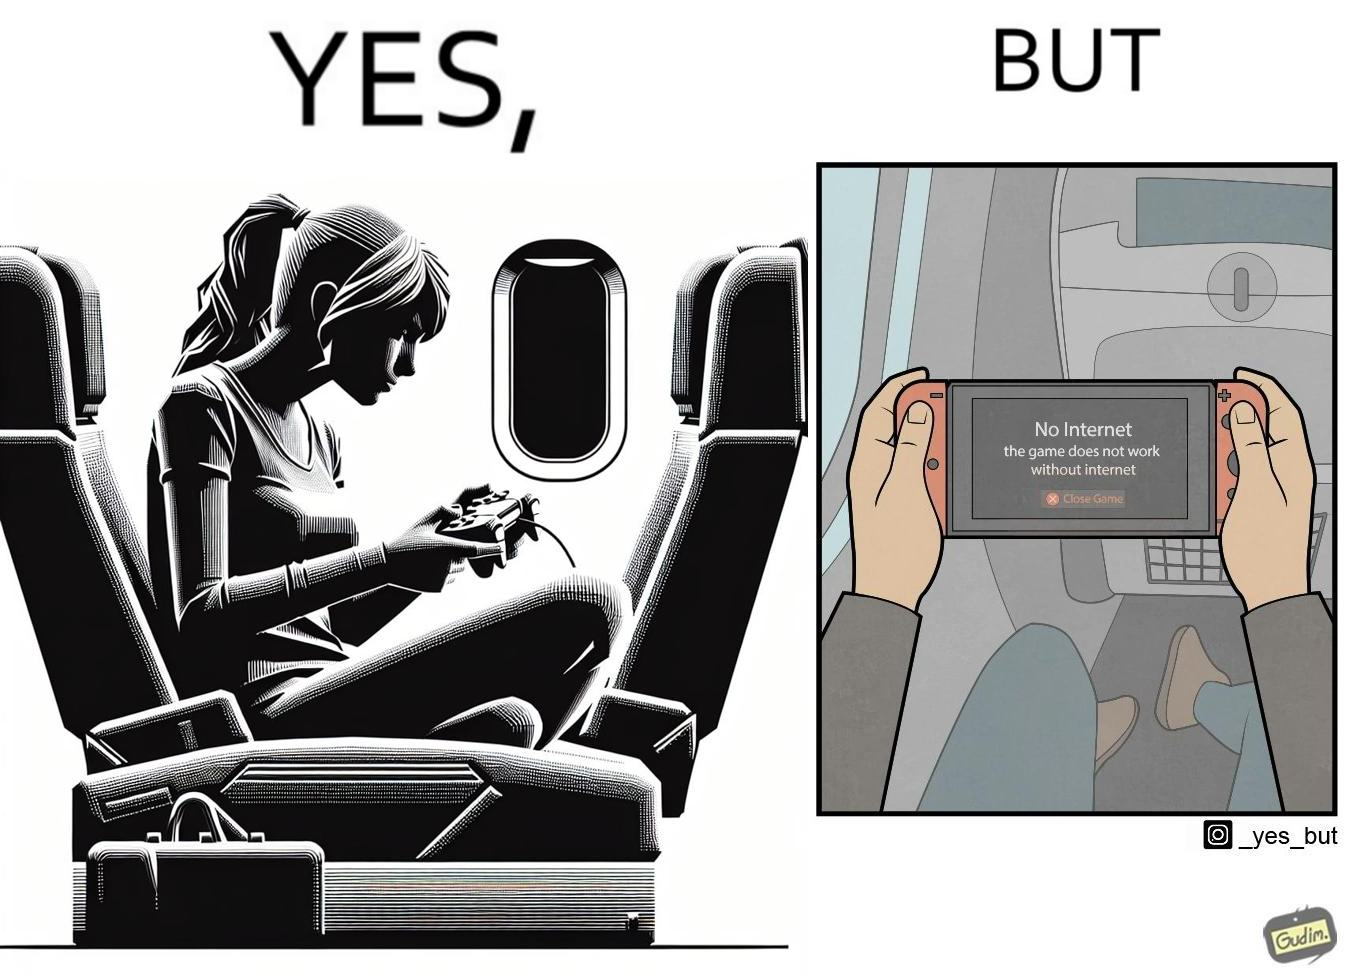Provide a description of this image. The image is ironic, as the person is holding the game console to play a game during the flight. However, the person is unable to play the game, as the game requires internet (as is the case with many modern games), and internet is unavailable in many lights. 